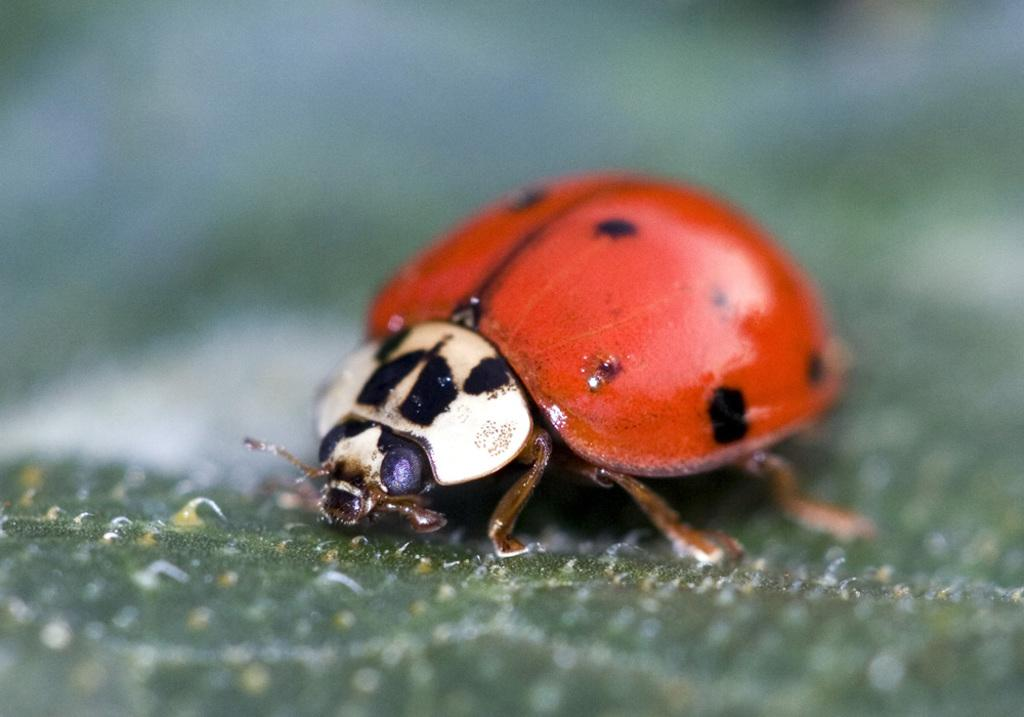What is the main subject of the image? There is an insect in the image. Where is the insect located in the image? The insect is in the middle of the image. What color can be seen on the insect's back side? The insect has a red color on its back side. What degree does the basketball player need to play professionally in the image? There is no basketball player or degree present in the image; it features an insect with a red color on its back side. 